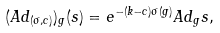Convert formula to latex. <formula><loc_0><loc_0><loc_500><loc_500>( A d _ { ( \sigma , c ) } ) _ { g } ( s ) = e ^ { - ( k - c ) \sigma ( g ) } A d _ { g } s ,</formula> 